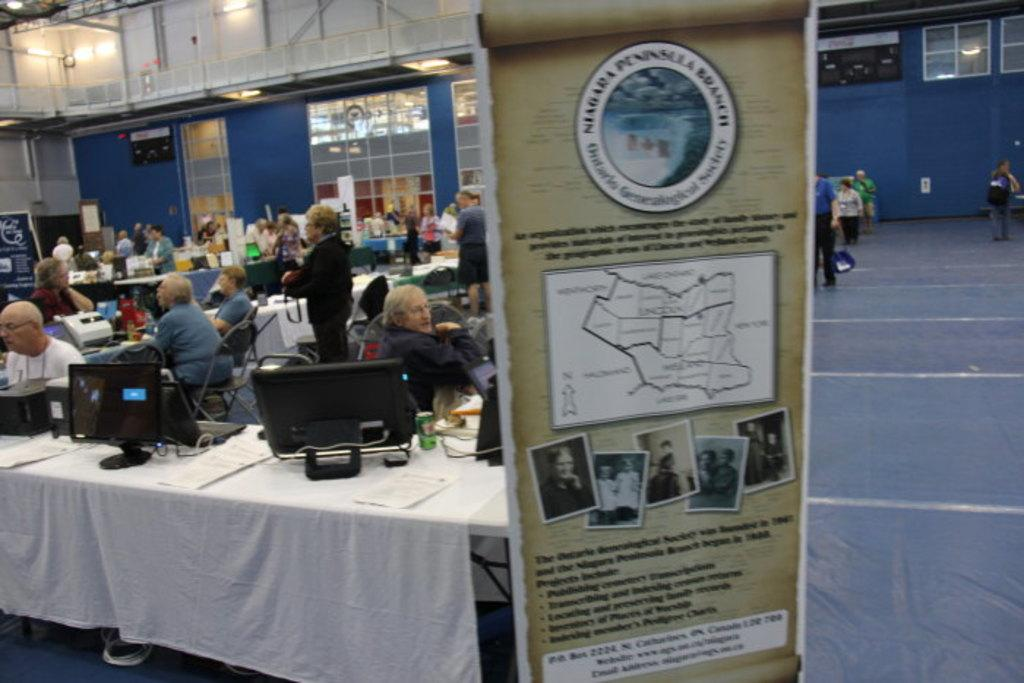Provide a one-sentence caption for the provided image. A vertical sign is displayed for the Niagara Pennsylvania Branch. 